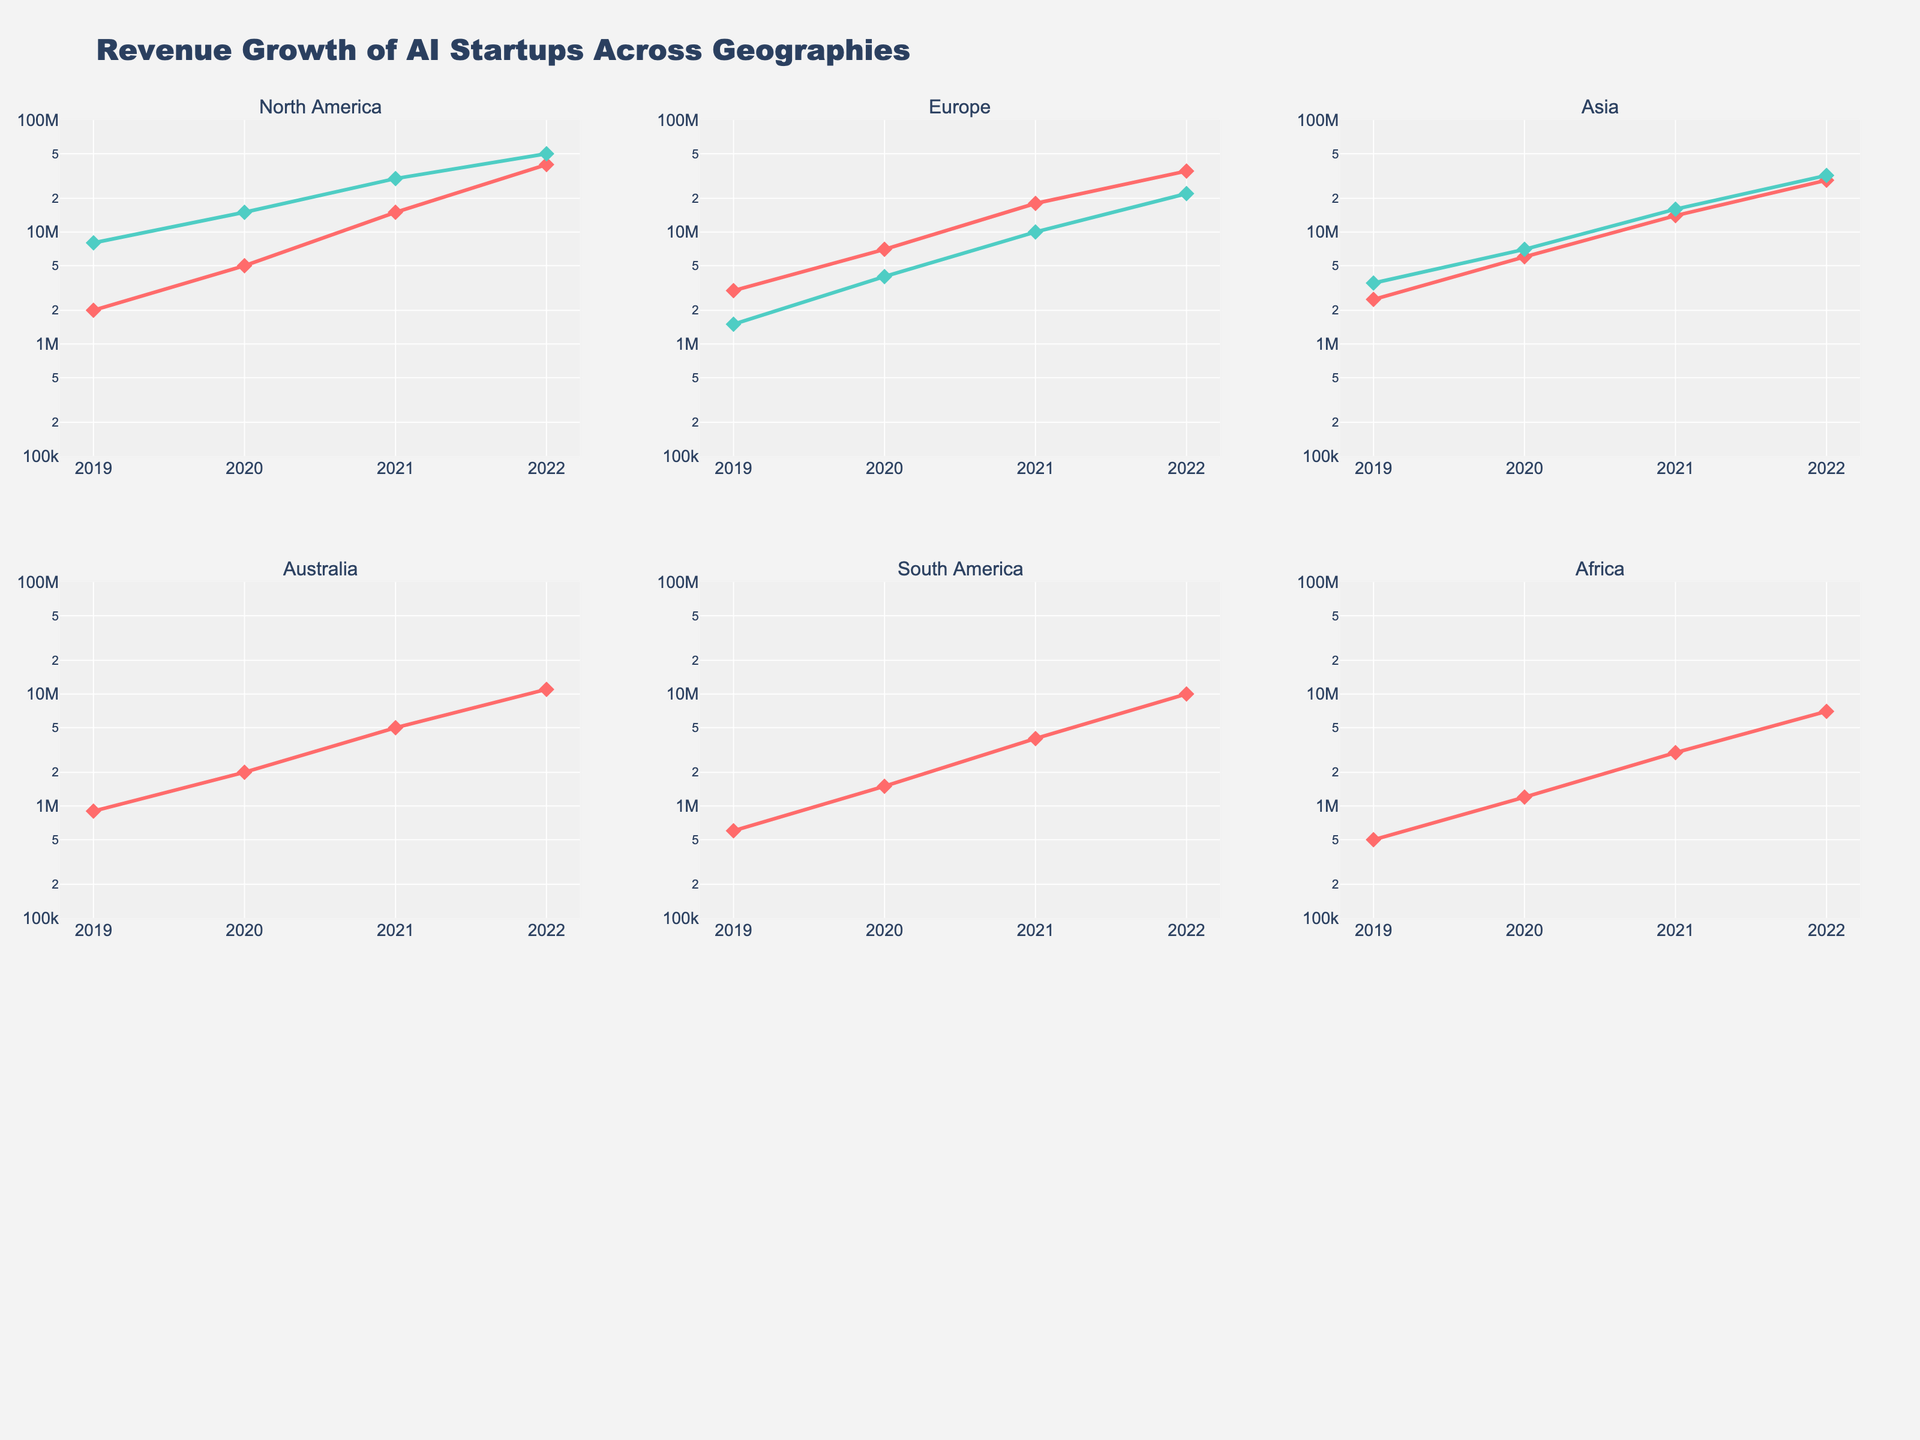Which geography shows the highest revenue for AI startups in 2022? By looking at the year 2022 on the x-axis for each subplot, find the highest point in each geography. The highest value appears in the North America subplot.
Answer: North America Which company in Europe had a higher revenue in 2020, DeepMind or Graphcore? Observe the lines for DeepMind and Graphcore in the Europe subplot at the year 2020. DeepMind's line is higher at this point.
Answer: DeepMind How does revenue growth for Harrison.AI compare with Kimera? Compare the slopes of Harrison.AI in the Australia subplot and Kimera in the South America subplot. Harrison.AI's slope shows a more rapid increase, indicating faster growth.
Answer: Harrison.AI What's the total revenue for OpenAI from 2019 to 2022? Sum up the revenue values for OpenAI from 2019 to 2022 (2M + 5M + 15M + 40M).
Answer: 62M Which company shows consistent exponential growth in the Asian market? Look for a smooth, continuously steepening curve in the Asia subplot. Sensetime's line follows this pattern.
Answer: Sensetime Does Baidu_AI have a steeper revenue growth compared to DeepMind? Compare the steepness of the curves for Baidu_AI in the Asia subplot and DeepMind in the Europe subplot. Baidu_AI's curve is steeper indicating higher growth rate.
Answer: Baidu_AI Which geography has the lowest initial revenue for any company in 2019? Check the 2019 revenue points in each subplot. Africa’s DataProphet has the lowest initial revenue.
Answer: Africa How does the revenue pattern of OpenAI differ from NVIDIA within North America? Compare the lines for OpenAI and NVIDIA in the North America subplot. OpenAI shows a more rapid and exponential growth pattern compared to a more linear increase for NVIDIA.
Answer: OpenAI In which year does Graphcore in Europe show the highest revenue jump? Compare the increments between years in the Europe subplot for Graphcore. The highest jump is between 2020 and 2021.
Answer: 2020-2021 